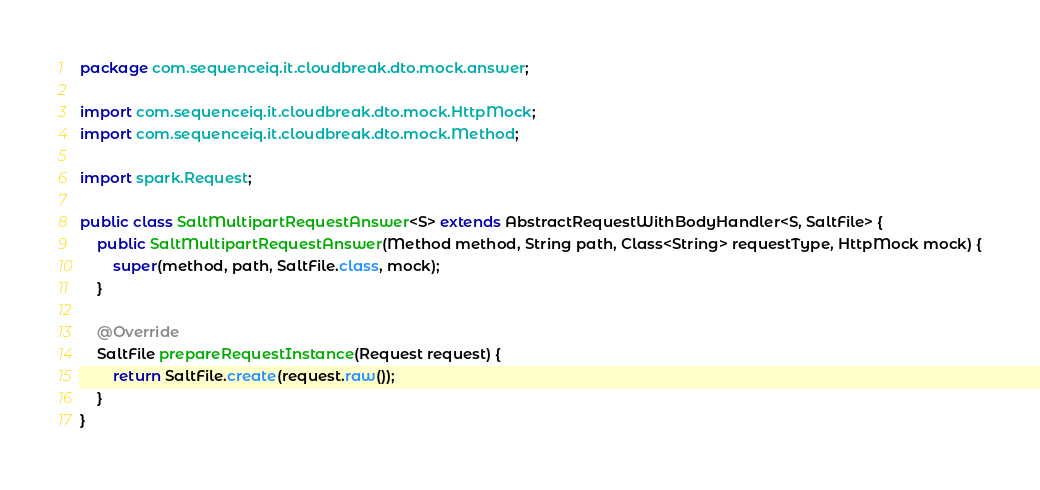Convert code to text. <code><loc_0><loc_0><loc_500><loc_500><_Java_>package com.sequenceiq.it.cloudbreak.dto.mock.answer;

import com.sequenceiq.it.cloudbreak.dto.mock.HttpMock;
import com.sequenceiq.it.cloudbreak.dto.mock.Method;

import spark.Request;

public class SaltMultipartRequestAnswer<S> extends AbstractRequestWithBodyHandler<S, SaltFile> {
    public SaltMultipartRequestAnswer(Method method, String path, Class<String> requestType, HttpMock mock) {
        super(method, path, SaltFile.class, mock);
    }

    @Override
    SaltFile prepareRequestInstance(Request request) {
        return SaltFile.create(request.raw());
    }
}
</code> 